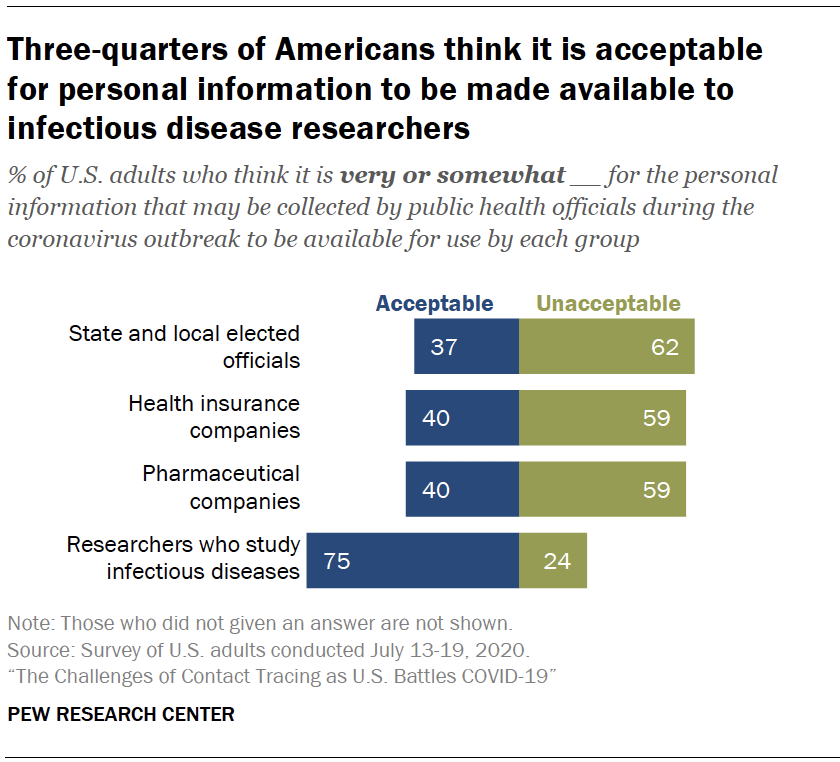List a handful of essential elements in this visual. The average of acceptable and unacceptable is 49, with acceptable being 48 and unacceptable being 51. Researchers who study infectious diseases must identify the category where acceptable and unacceptable gaps are more prevalent. 